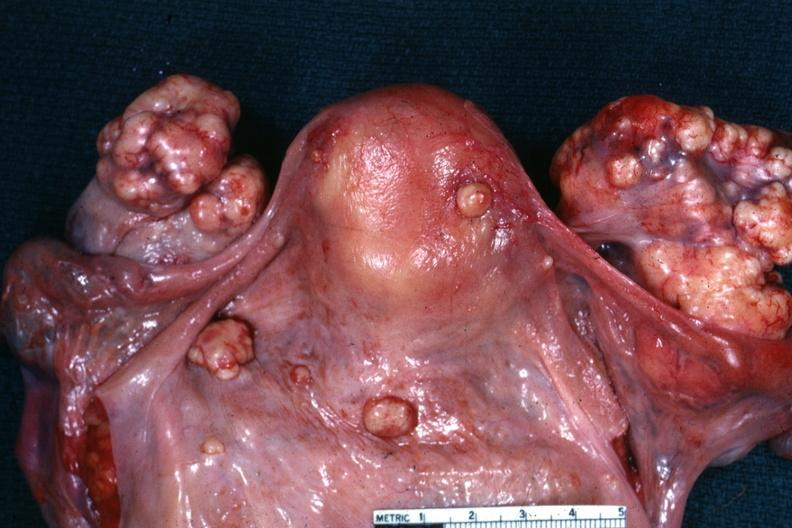what was view of uterus tubes and ovaries showing large nodular metastatic tumor masses on ovaries and peritoneal surface of uterus and douglas pouch outstanding photo primary in this is true bilateral krukenberg?
Answer the question using a single word or phrase. In the stomach 